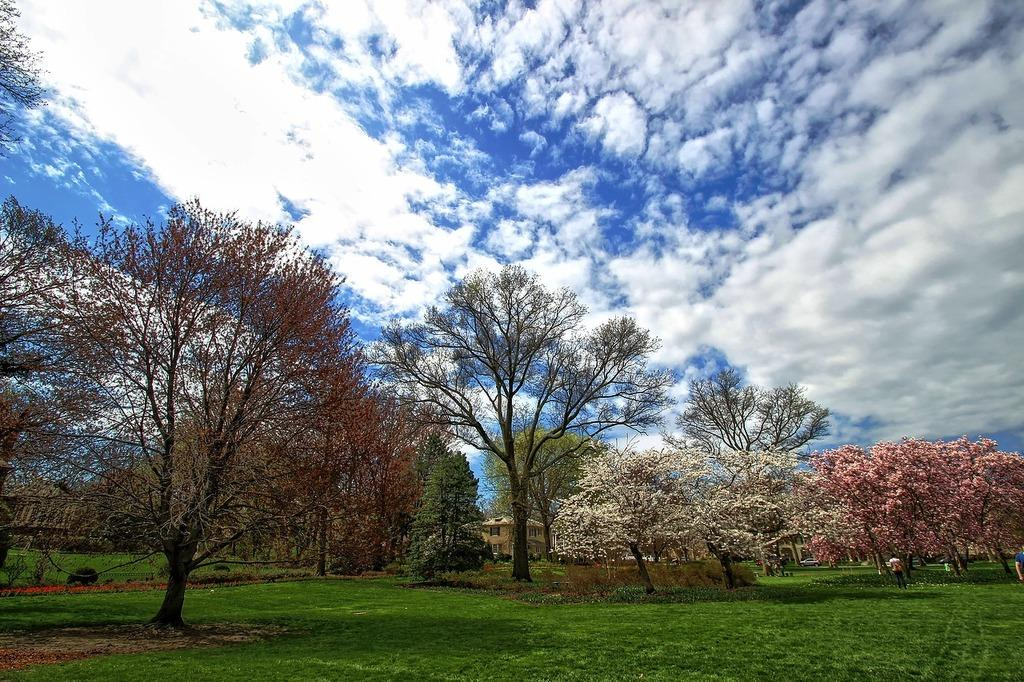What can be seen in the sky in the image? The sky with clouds is visible in the image. What type of structures are present in the image? There are buildings in the image. What type of vegetation is present in the image? Trees and bushes are visible in the image. What is the person in the image doing? There is a person standing on the ground in the image. What type of tin can be seen growing in the image? There is no tin present in the image, and therefore no such growth can be observed. 